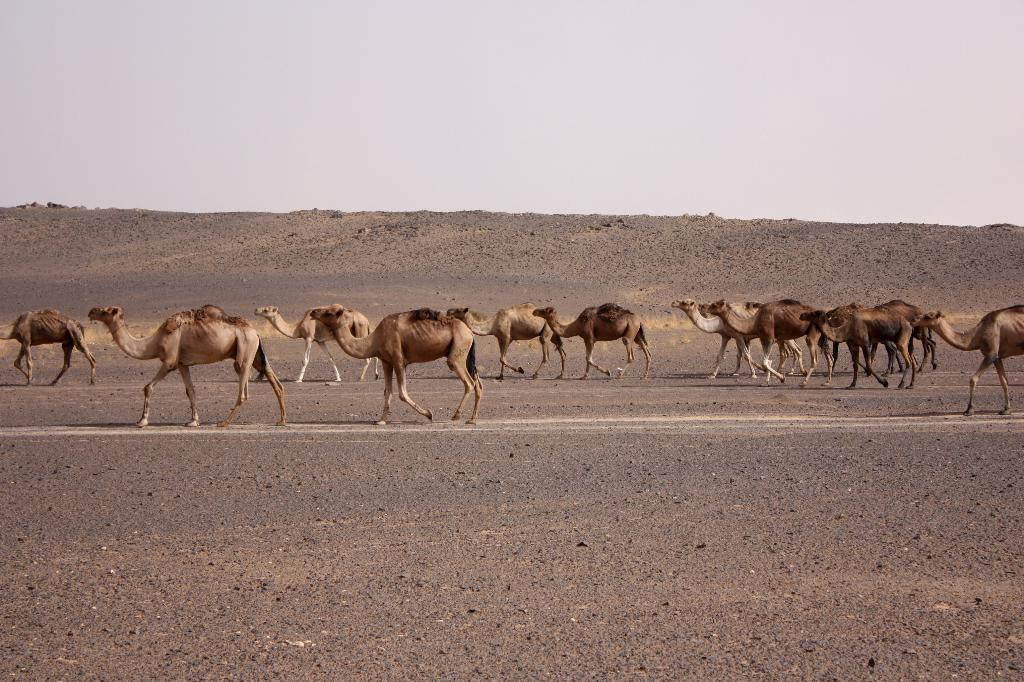What animals are present in the image? There are camels in the image. What are the camels doing in the image? The camels are walking in a field. What can be seen in the background of the image? There is a sky visible in the background. How many dogs are present in the image? There are no dogs present in the image; it features camels walking in a field. 